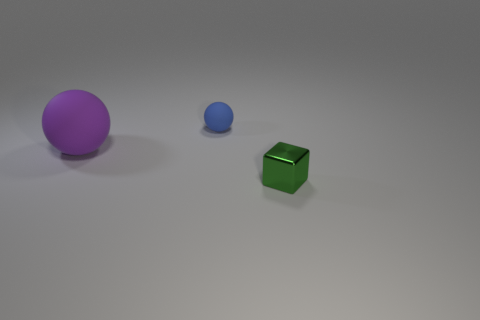Is there any other thing that has the same material as the tiny green cube?
Your answer should be compact. No. Are there any other things that have the same size as the purple matte object?
Offer a very short reply. No. There is a purple rubber sphere; is it the same size as the thing that is on the right side of the blue matte ball?
Your answer should be compact. No. There is a small thing in front of the tiny blue rubber ball; what is its material?
Provide a succinct answer. Metal. There is a tiny object that is behind the tiny green object; how many metal things are right of it?
Make the answer very short. 1. Are there any other small rubber things of the same shape as the purple thing?
Give a very brief answer. Yes. Does the matte ball behind the big purple sphere have the same size as the sphere in front of the blue sphere?
Keep it short and to the point. No. The tiny object that is behind the tiny object in front of the purple ball is what shape?
Make the answer very short. Sphere. What number of blue shiny spheres have the same size as the blue matte object?
Provide a short and direct response. 0. Is there a big gray ball?
Your answer should be compact. No. 